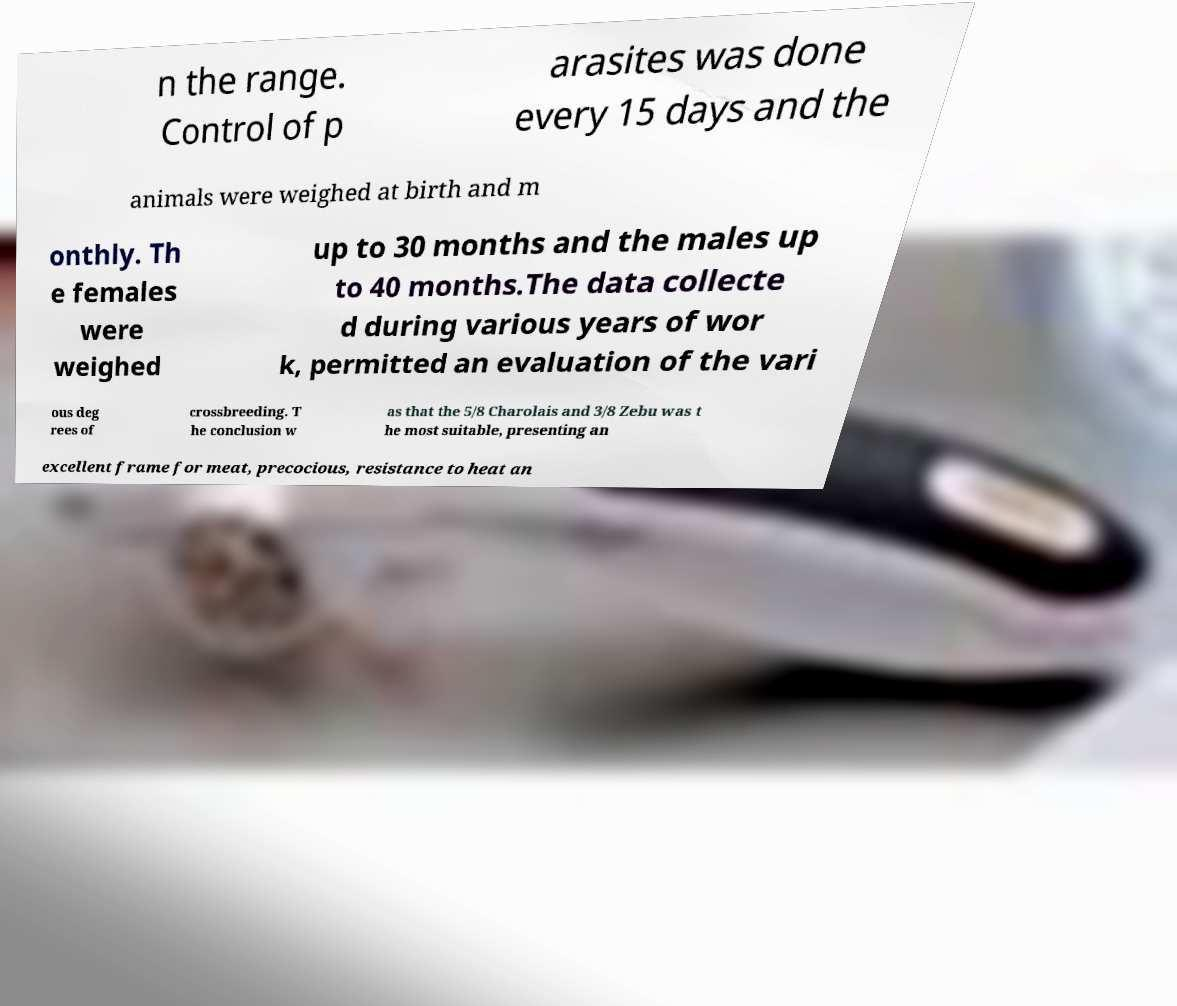I need the written content from this picture converted into text. Can you do that? n the range. Control of p arasites was done every 15 days and the animals were weighed at birth and m onthly. Th e females were weighed up to 30 months and the males up to 40 months.The data collecte d during various years of wor k, permitted an evaluation of the vari ous deg rees of crossbreeding. T he conclusion w as that the 5/8 Charolais and 3/8 Zebu was t he most suitable, presenting an excellent frame for meat, precocious, resistance to heat an 